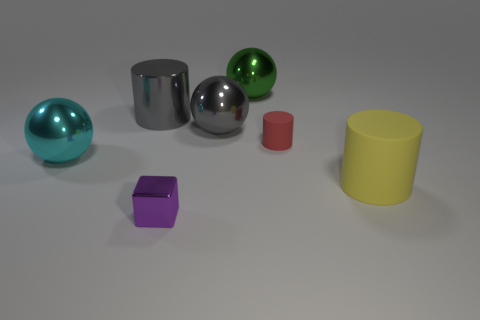Does the gray thing to the right of the metal cylinder have the same size as the gray metallic thing left of the small purple shiny cube?
Make the answer very short. Yes. How many big blue objects are there?
Offer a terse response. 0. How big is the cylinder left of the large green object that is to the left of the tiny object that is behind the purple block?
Your response must be concise. Large. How many small red rubber cylinders are left of the large metal cylinder?
Your answer should be compact. 0. Is the number of green balls behind the green shiny thing the same as the number of small blue shiny things?
Provide a succinct answer. Yes. What number of objects are either gray matte objects or small red cylinders?
Ensure brevity in your answer.  1. Is there any other thing that has the same shape as the purple metallic object?
Offer a very short reply. No. There is a big metallic object that is behind the cylinder left of the green metallic object; what is its shape?
Keep it short and to the point. Sphere. The small red thing that is the same material as the yellow cylinder is what shape?
Your response must be concise. Cylinder. What size is the matte cylinder that is in front of the small object to the right of the small shiny thing?
Provide a short and direct response. Large. 